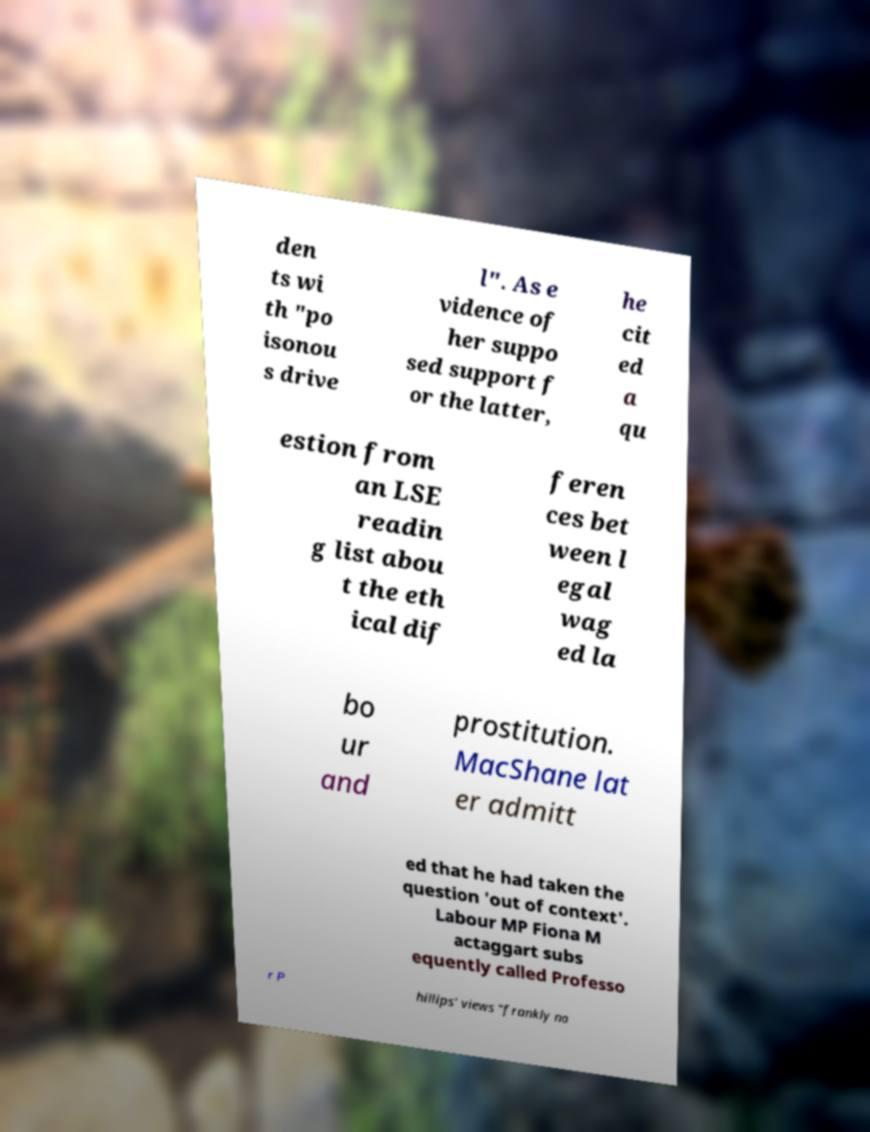Please read and relay the text visible in this image. What does it say? den ts wi th "po isonou s drive l". As e vidence of her suppo sed support f or the latter, he cit ed a qu estion from an LSE readin g list abou t the eth ical dif feren ces bet ween l egal wag ed la bo ur and prostitution. MacShane lat er admitt ed that he had taken the question 'out of context'. Labour MP Fiona M actaggart subs equently called Professo r P hillips' views "frankly na 